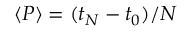<formula> <loc_0><loc_0><loc_500><loc_500>\langle P \rangle = ( t _ { N } - t _ { 0 } ) / N</formula> 